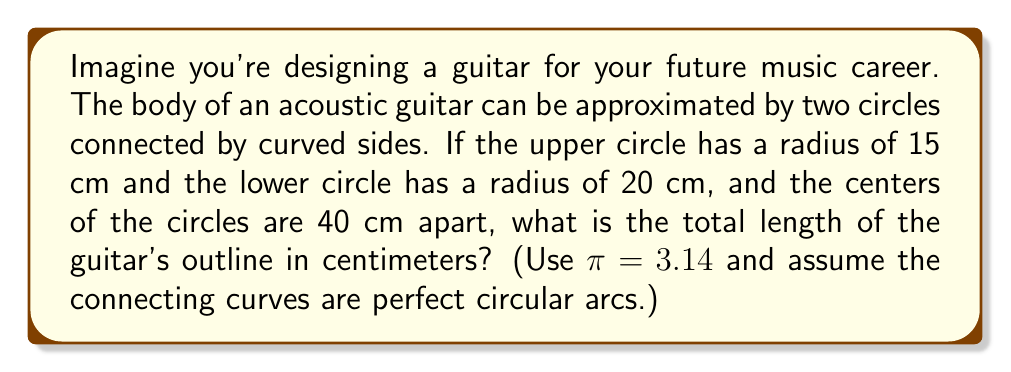Solve this math problem. Let's break this down step-by-step:

1) First, we need to calculate the circumferences of both circles:
   Upper circle: $C_1 = 2\pi r_1 = 2 \cdot 3.14 \cdot 15 = 94.2$ cm
   Lower circle: $C_2 = 2\pi r_2 = 2 \cdot 3.14 \cdot 20 = 125.6$ cm

2) We only need half of each circle for the guitar's outline:
   Upper half-circle: $94.2 \div 2 = 47.1$ cm
   Lower half-circle: $125.6 \div 2 = 62.8$ cm

3) Now, we need to calculate the length of the curved sides. These can be modeled as circular arcs. To find their length, we need to know the radius of these arcs.

4) The radius of these arcs can be calculated using the Pythagorean theorem:
   $$R^2 = (\frac{40}{2})^2 + (20-15)^2$$
   $$R^2 = 20^2 + 5^2 = 400 + 25 = 425$$
   $$R = \sqrt{425} \approx 20.62$$ cm

5) The arc length formula is $L = R\theta$, where $\theta$ is in radians. We can find $\theta$ using:
   $$\sin(\frac{\theta}{2}) = \frac{20}{20.62} \approx 0.97$$
   $$\frac{\theta}{2} = \arcsin(0.97) \approx 1.31$$
   $$\theta \approx 2.62$$ radians

6) Now we can calculate the length of one arc:
   $L = 20.62 \cdot 2.62 \approx 54$ cm

7) There are two such arcs, so the total length of the curved sides is $2 \cdot 54 = 108$ cm

8) The total outline length is the sum of all these parts:
   $47.1 + 62.8 + 108 = 217.9$ cm
Answer: 218 cm 